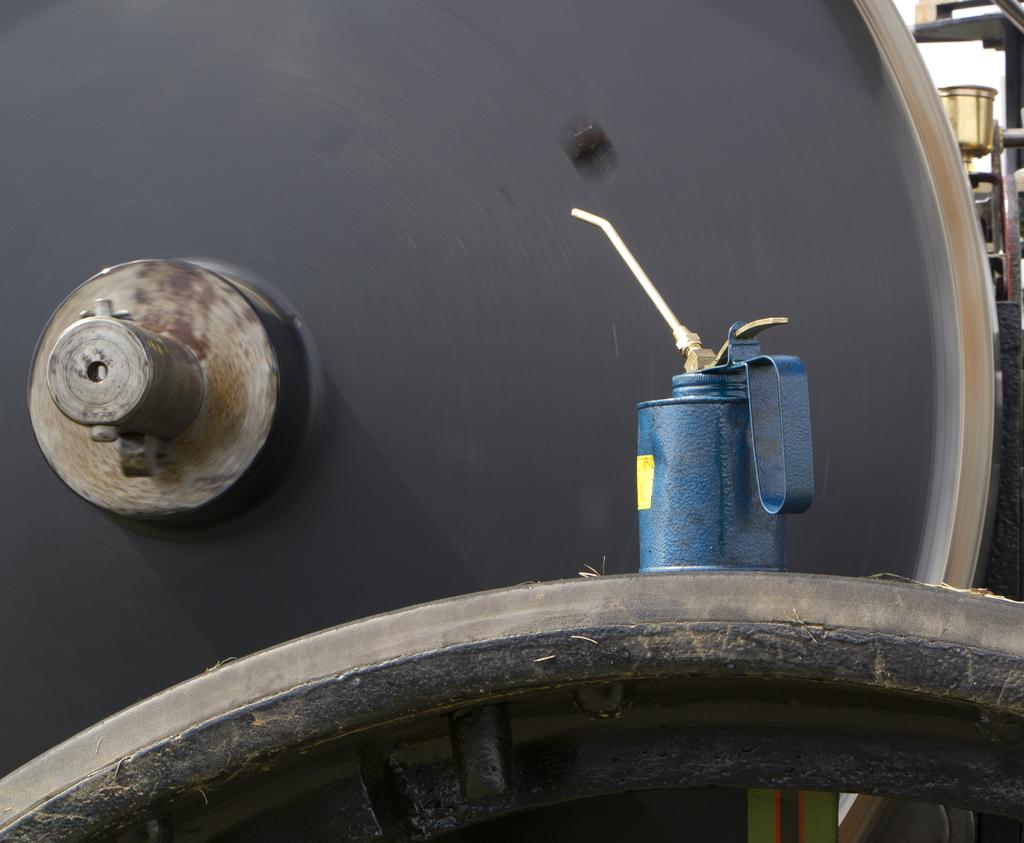What object is located on the right side of the image? There is a spray on the right side of the image. What other object can be seen in the image? There is an iron in the image. What color is the background of the image? The background of the image is black. What is the chance of winning a basketball game in the image? There is no reference to a basketball game or any chances of winning in the image. Can you see someone's ear in the image? There is no ear visible in the image; it only features a spray and an iron. 